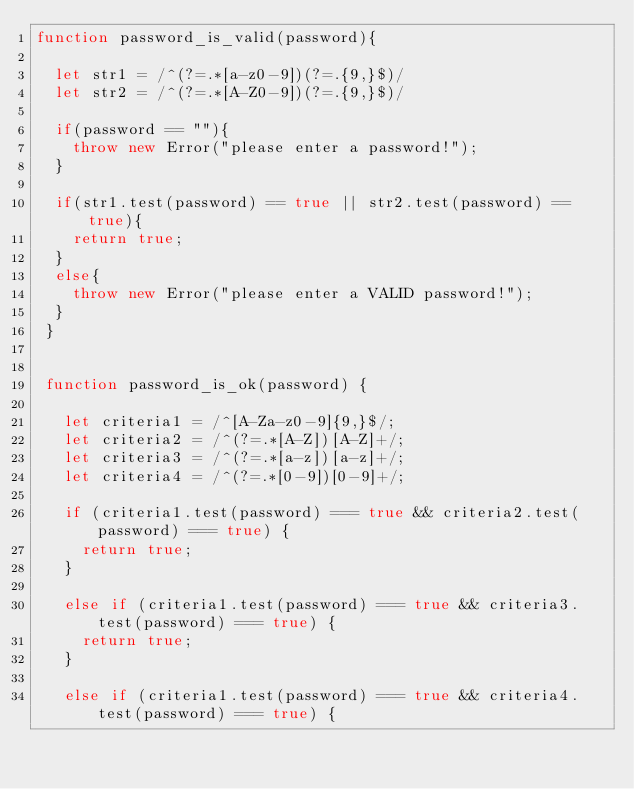Convert code to text. <code><loc_0><loc_0><loc_500><loc_500><_JavaScript_>function password_is_valid(password){
   
  let str1 = /^(?=.*[a-z0-9])(?=.{9,}$)/
  let str2 = /^(?=.*[A-Z0-9])(?=.{9,}$)/

  if(password == ""){
    throw new Error("please enter a password!");
  }

  if(str1.test(password) == true || str2.test(password) == true){
    return true;
  }  
  else{
    throw new Error("please enter a VALID password!");
  }
 } 
 
 
 function password_is_ok(password) {
   
   let criteria1 = /^[A-Za-z0-9]{9,}$/;
   let criteria2 = /^(?=.*[A-Z])[A-Z]+/;
   let criteria3 = /^(?=.*[a-z])[a-z]+/;
   let criteria4 = /^(?=.*[0-9])[0-9]+/;
 
   if (criteria1.test(password) === true && criteria2.test(password) === true) {
     return true;
   }

   else if (criteria1.test(password) === true && criteria3.test(password) === true) {
     return true;
   }

   else if (criteria1.test(password) === true && criteria4.test(password) === true) {</code> 